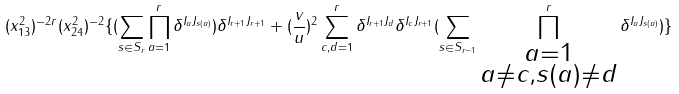Convert formula to latex. <formula><loc_0><loc_0><loc_500><loc_500>( x ^ { 2 } _ { 1 3 } ) ^ { - 2 r } ( x ^ { 2 } _ { 2 4 } ) ^ { - 2 } \{ ( \sum _ { s \in S _ { r } } \prod _ { a = 1 } ^ { r } \delta ^ { I _ { a } J _ { s ( a ) } } ) \delta ^ { I _ { r + 1 } J _ { r + 1 } } + ( \frac { v } { u } ) ^ { 2 } \sum _ { c , d = 1 } ^ { r } \delta ^ { I _ { r + 1 } J _ { d } } \delta ^ { I _ { c } J _ { r + 1 } } ( \sum _ { s \in S _ { r - 1 } } \prod _ { \substack { a = 1 \\ a \neq c , s ( a ) \neq d } } ^ { r } \delta ^ { I _ { a } J _ { s ( a ) } } ) \}</formula> 